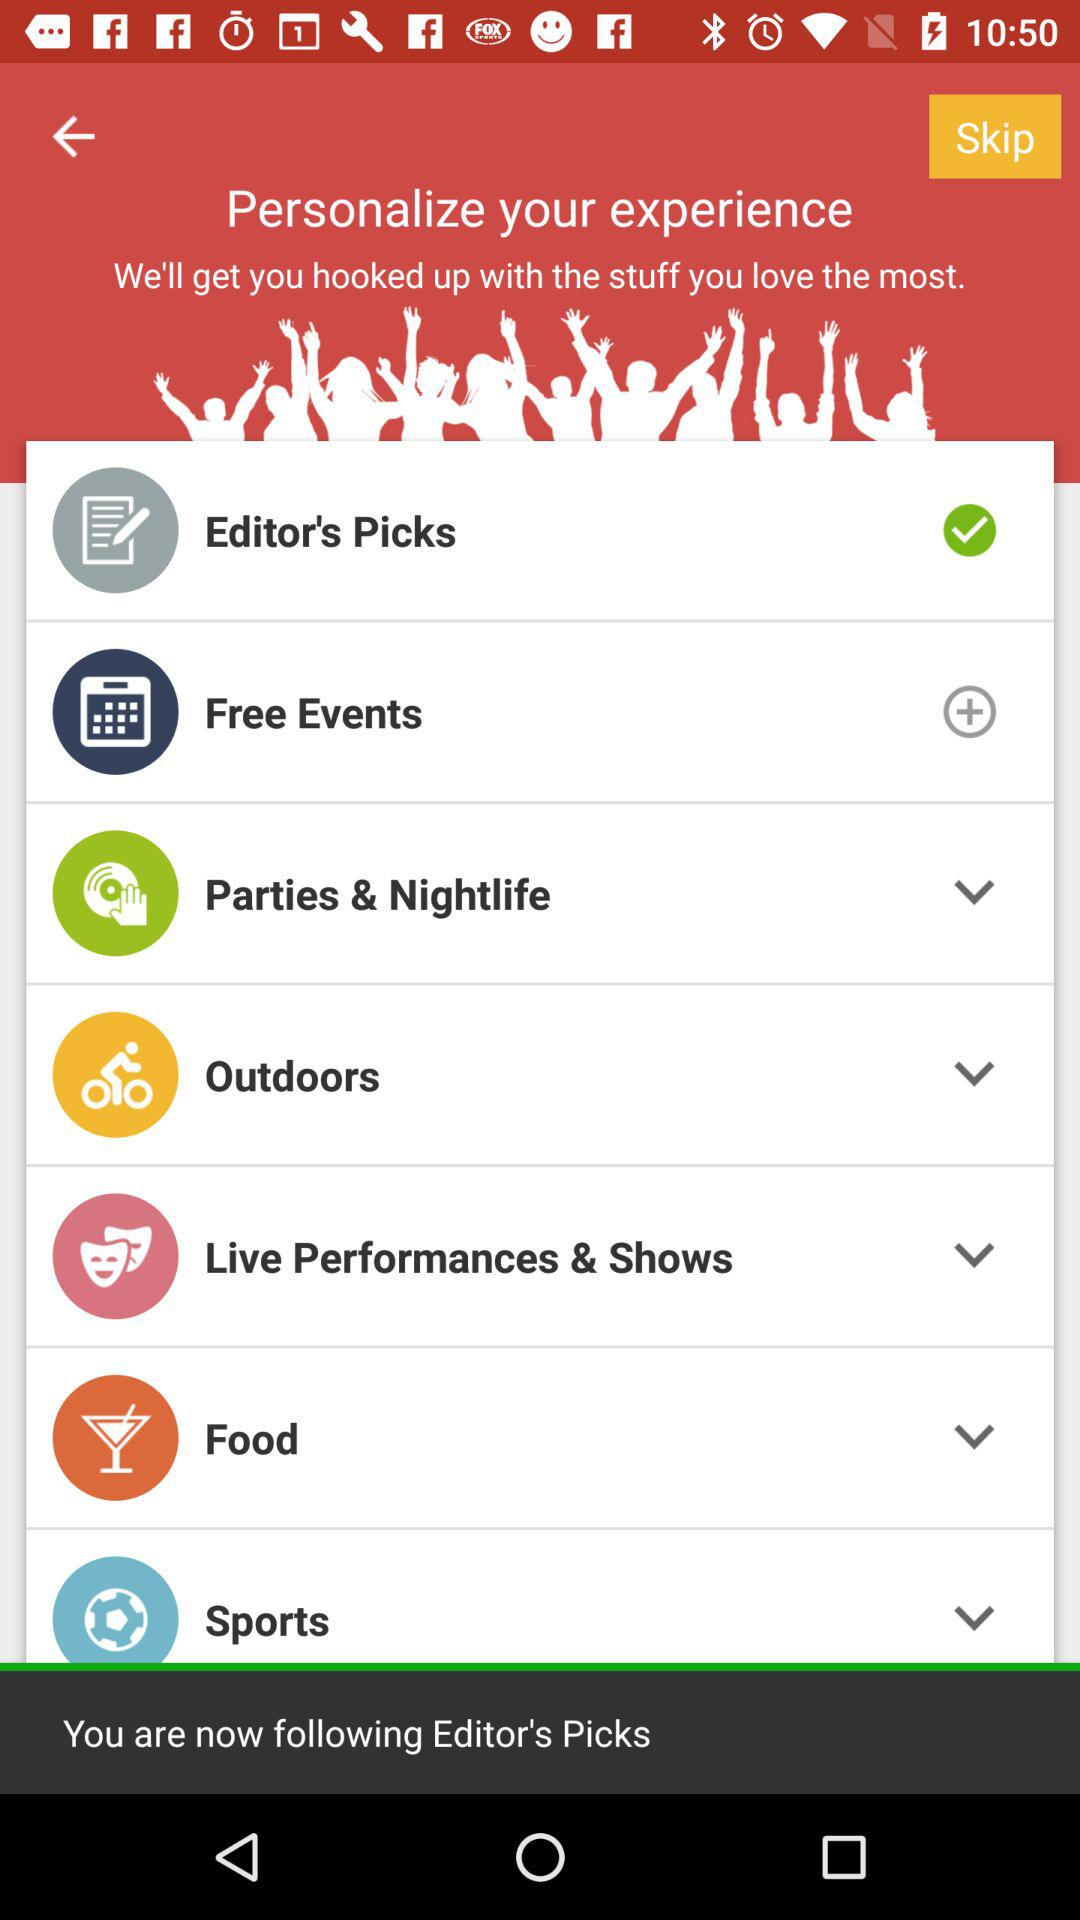What is the selected option? The selected option is "Editor's Picks". 